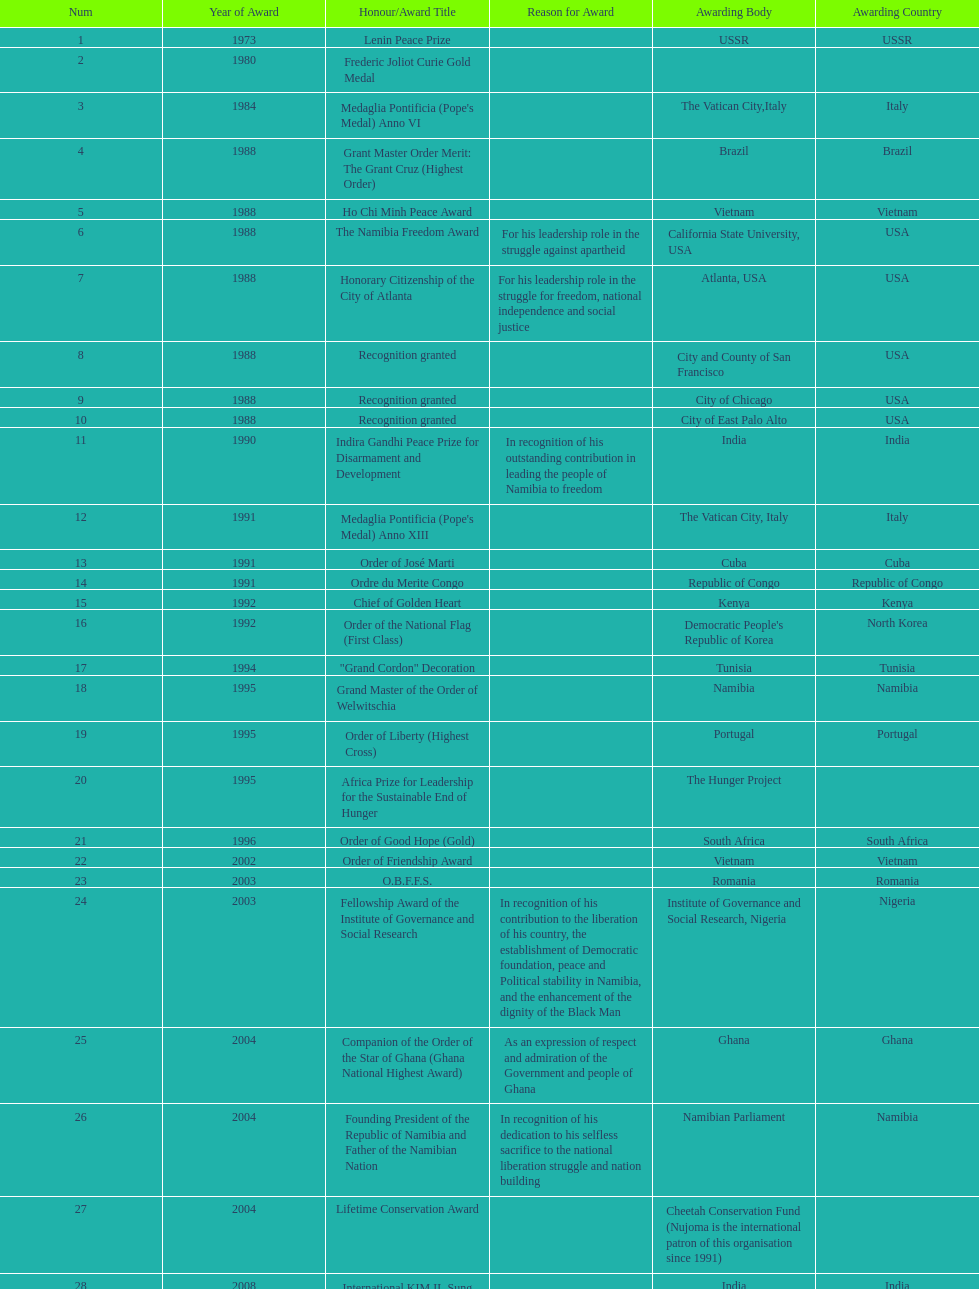What were the total number of honors/award titles listed according to this chart? 29. 